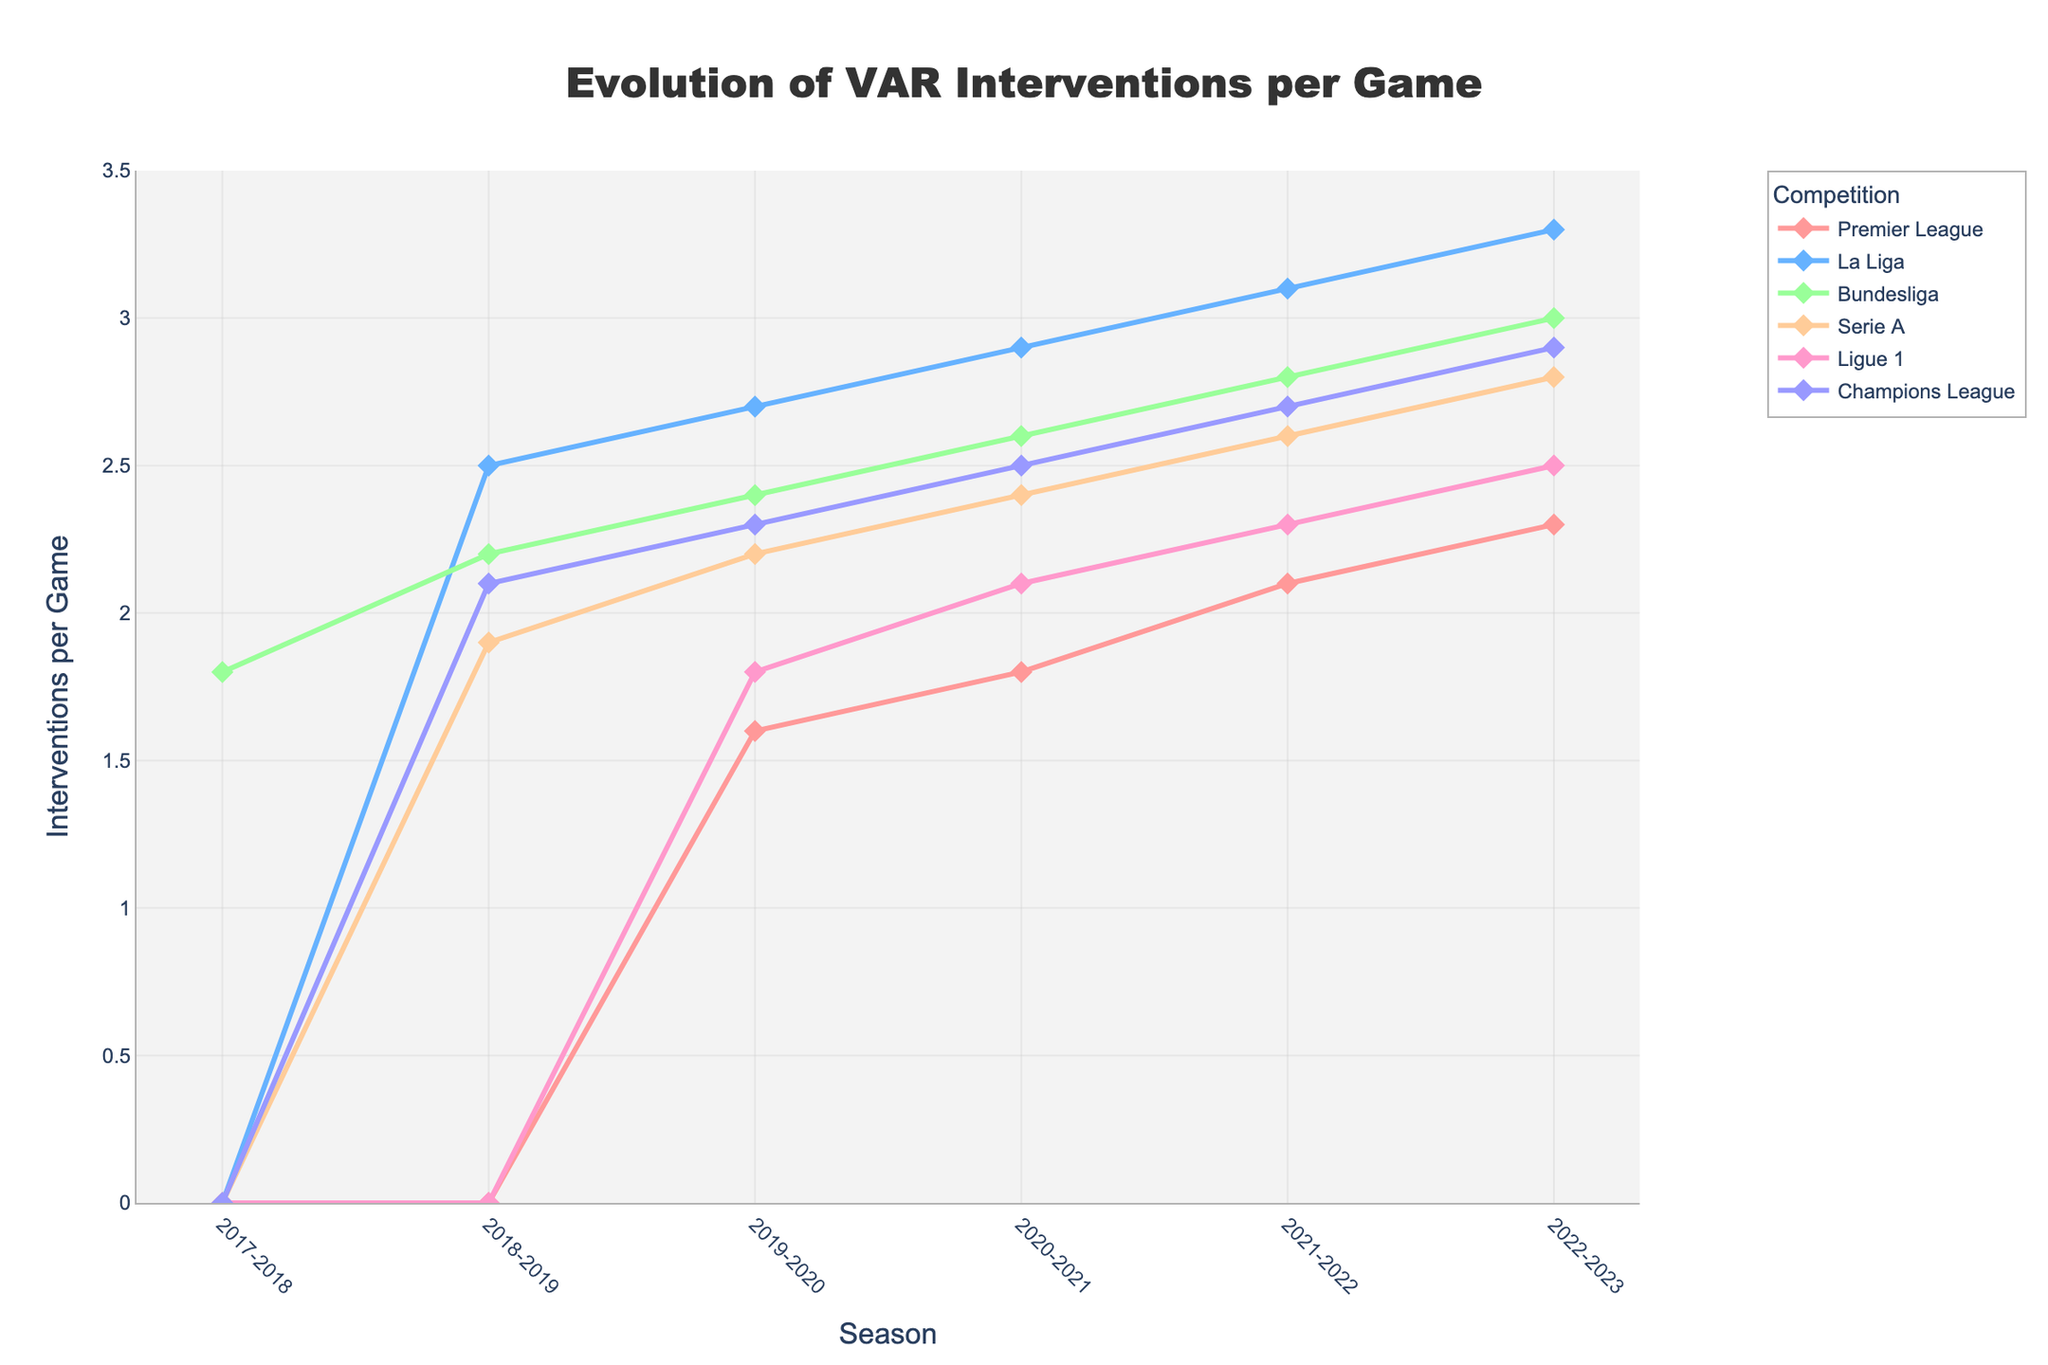How did VAR interventions per game evolve in the Premier League from 2017-2018 to 2022-2023? Starting from 0.0 in 2017-2018, the number of VAR interventions per game gradually increased each season: it reached 1.6 in 2019-2020, 1.8 in 2020-2021, 2.1 in 2021-2022, and finally 2.3 in 2022-2023.
Answer: Increased Which competition had the most significant increase in VAR interventions per game between 2017-2018 and 2022-2023? By comparing all competitions, La Liga had the most significant increase, going from 0.0 in 2017-2018 to 3.3 in 2022-2023, which is a 3.3 increase.
Answer: La Liga In the 2022-2023 season, which competition had the highest number of VAR interventions per game and which had the lowest? In the 2022-2023 season, La Liga had the highest number of VAR interventions per game with 3.3, and the Premier League had the lowest with 2.3.
Answer: La Liga highest, Premier League lowest Compare the trends of VAR interventions per game in Serie A and Bundesliga from 2017-2018 to 2022-2023. Both Serie A and the Bundesliga experienced an increase in VAR interventions per game, but the Bundesliga started at 1.8 in 2017-2018 while Serie A started at 0.0. By 2022-2023, the Bundesliga had reached 3.0 and Serie A had reached 2.8, showing a persistent increase in both leagues.
Answer: Both increased, Bundesliga higher than Serie A Calculate the average number of VAR interventions per game for the Champions League from 2017-2018 to 2022-2023. The data points for VAR interventions per game for the Champions League are 0.0, 2.1, 2.3, 2.5, 2.7, and 2.9. Summing these values: 0.0 + 2.1 + 2.3 + 2.5 + 2.7 + 2.9 = 12.5. Then, dividing by the number of seasons (6): 12.5 / 6 ≈ 2.08.
Answer: 2.08 In which season did the Premier League first introduce VAR interventions, and what was the number? The Premier League first introduced VAR interventions in the 2019-2020 season with 1.6 interventions per game.
Answer: 2019-2020, 1.6 Which competition showed a consistent yearly increase in VAR interventions from its introduction until 2022-2023? La Liga showed a consistent yearly increase in VAR interventions per game each season from its introduction until 2022-2023.
Answer: La Liga Between the seasons of 2019-2020 and 2022-2023, how much did the number of VAR interventions per game increase in the Ligue 1? In the 2019-2020 season, Ligue 1 had 1.8 interventions per game, and by the 2022-2023 season, it had 2.5. The increase is calculated as 2.5 - 1.8 = 0.7.
Answer: 0.7 Is there any season where all competitions had some level of VAR interventions, and if so, which season? Starting in the 2019-2020 season and onwards, all competitions mentioned had some level of VAR interventions each season.
Answer: 2019-2020 season and onwards 